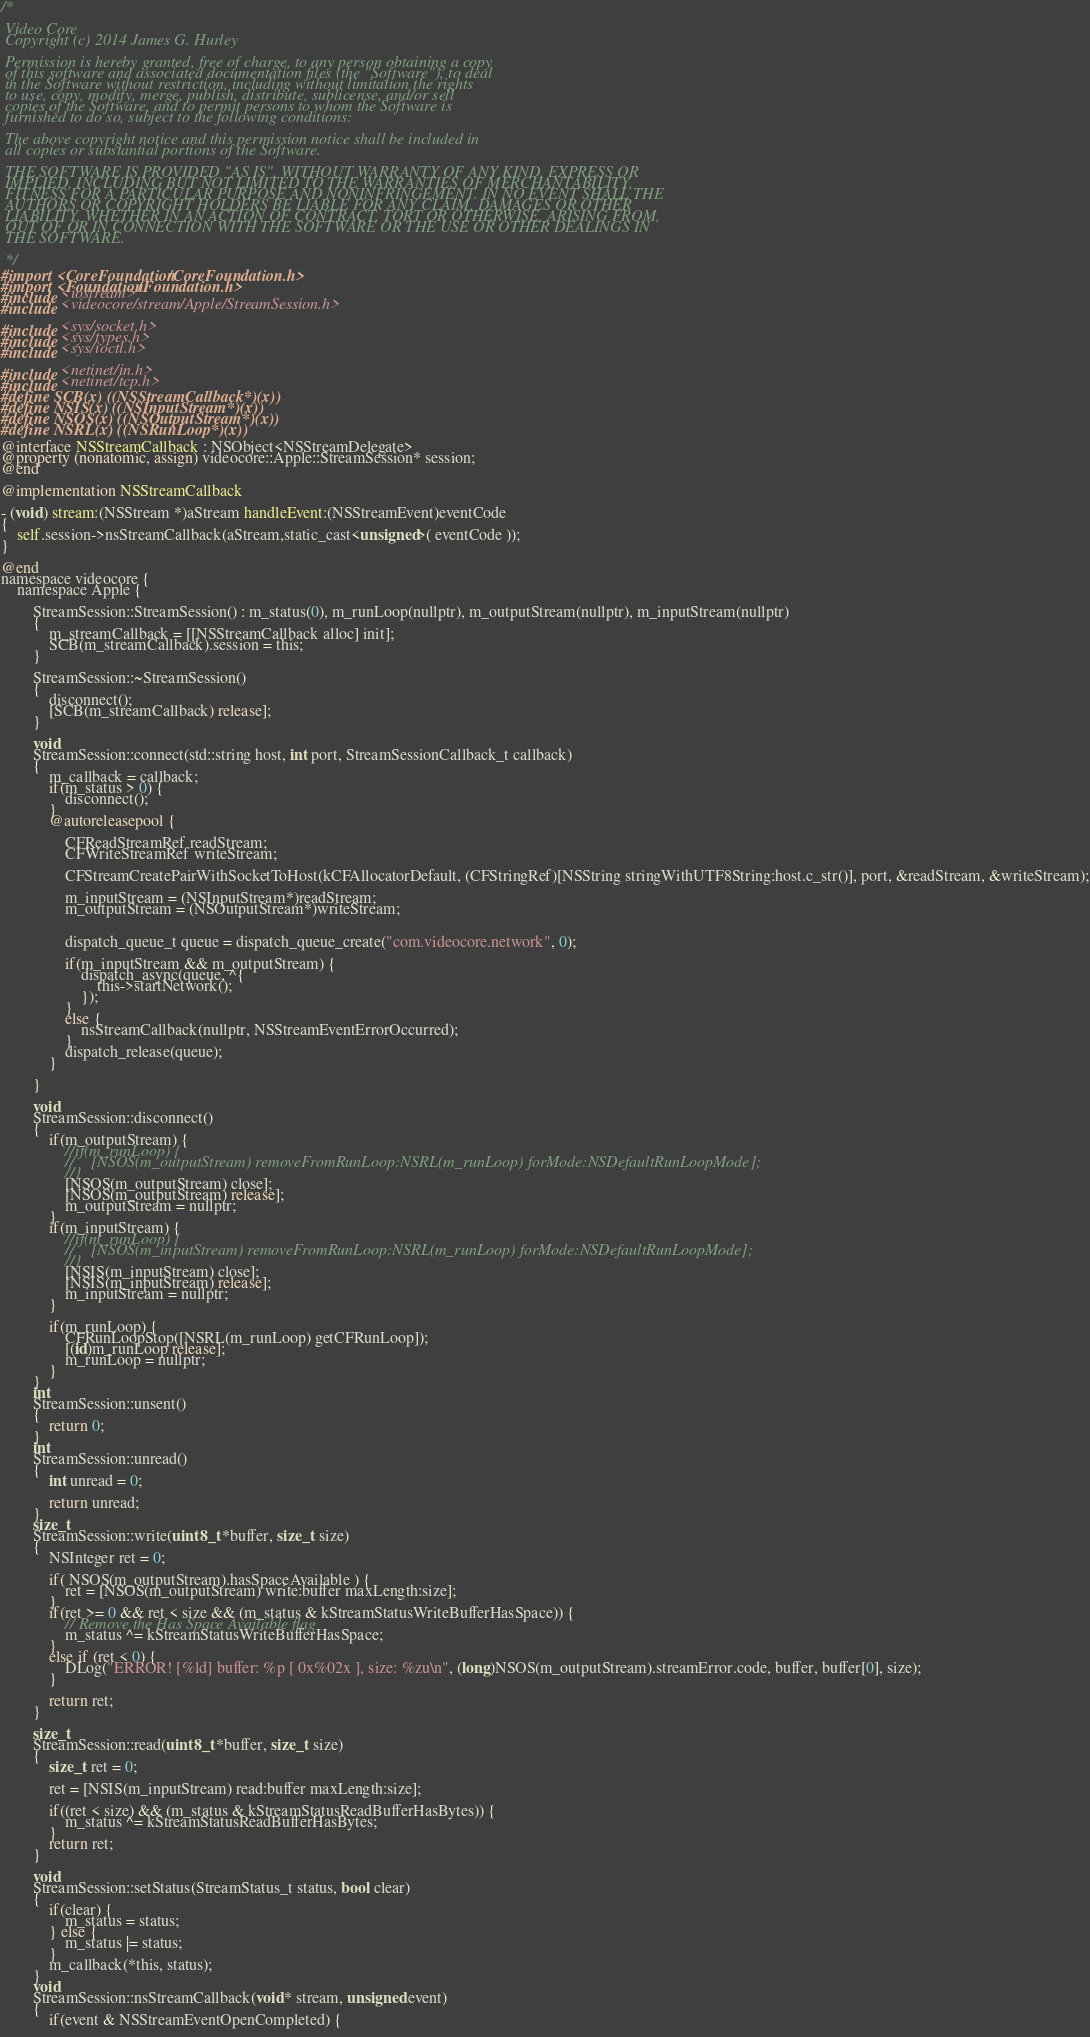<code> <loc_0><loc_0><loc_500><loc_500><_ObjectiveC_>/*
 
 Video Core
 Copyright (c) 2014 James G. Hurley
 
 Permission is hereby granted, free of charge, to any person obtaining a copy
 of this software and associated documentation files (the "Software"), to deal
 in the Software without restriction, including without limitation the rights
 to use, copy, modify, merge, publish, distribute, sublicense, and/or sell
 copies of the Software, and to permit persons to whom the Software is
 furnished to do so, subject to the following conditions:
 
 The above copyright notice and this permission notice shall be included in
 all copies or substantial portions of the Software.
 
 THE SOFTWARE IS PROVIDED "AS IS", WITHOUT WARRANTY OF ANY KIND, EXPRESS OR
 IMPLIED, INCLUDING BUT NOT LIMITED TO THE WARRANTIES OF MERCHANTABILITY,
 FITNESS FOR A PARTICULAR PURPOSE AND NONINFRINGEMENT. IN NO EVENT SHALL THE
 AUTHORS OR COPYRIGHT HOLDERS BE LIABLE FOR ANY CLAIM, DAMAGES OR OTHER
 LIABILITY, WHETHER IN AN ACTION OF CONTRACT, TORT OR OTHERWISE, ARISING FROM,
 OUT OF OR IN CONNECTION WITH THE SOFTWARE OR THE USE OR OTHER DEALINGS IN
 THE SOFTWARE.
 
 */
#import <CoreFoundation/CoreFoundation.h>
#import <Foundation/Foundation.h>
#include <iostream>
#include <videocore/stream/Apple/StreamSession.h>

#include <sys/socket.h>
#include <sys/types.h>
#include <sys/ioctl.h>

#include <netinet/in.h>
#include <netinet/tcp.h>
#define SCB(x) ((NSStreamCallback*)(x))
#define NSIS(x) ((NSInputStream*)(x))
#define NSOS(x) ((NSOutputStream*)(x))
#define NSRL(x) ((NSRunLoop*)(x))

@interface NSStreamCallback : NSObject<NSStreamDelegate>
@property (nonatomic, assign) videocore::Apple::StreamSession* session;
@end

@implementation NSStreamCallback

- (void) stream:(NSStream *)aStream handleEvent:(NSStreamEvent)eventCode
{
    self.session->nsStreamCallback(aStream,static_cast<unsigned>( eventCode ));
}

@end
namespace videocore {
    namespace Apple {
        
        StreamSession::StreamSession() : m_status(0), m_runLoop(nullptr), m_outputStream(nullptr), m_inputStream(nullptr)
        {
            m_streamCallback = [[NSStreamCallback alloc] init];
            SCB(m_streamCallback).session = this;
        }
        
        StreamSession::~StreamSession()
        {
            disconnect();
            [SCB(m_streamCallback) release];
        }
        
        void
        StreamSession::connect(std::string host, int port, StreamSessionCallback_t callback)
        {
            m_callback = callback;
            if(m_status > 0) {
                disconnect();
            }
            @autoreleasepool {
                
                CFReadStreamRef readStream;
                CFWriteStreamRef writeStream;

                CFStreamCreatePairWithSocketToHost(kCFAllocatorDefault, (CFStringRef)[NSString stringWithUTF8String:host.c_str()], port, &readStream, &writeStream);
            
                m_inputStream = (NSInputStream*)readStream;
                m_outputStream = (NSOutputStream*)writeStream;
            

                dispatch_queue_t queue = dispatch_queue_create("com.videocore.network", 0);
                
                if(m_inputStream && m_outputStream) {
                    dispatch_async(queue, ^{
                        this->startNetwork();
                    });
                }
                else {
                    nsStreamCallback(nullptr, NSStreamEventErrorOccurred);
                }
                dispatch_release(queue);
            }

        }
        
        void
        StreamSession::disconnect()
        {
            if(m_outputStream) {
                //if(m_runLoop) {
                //    [NSOS(m_outputStream) removeFromRunLoop:NSRL(m_runLoop) forMode:NSDefaultRunLoopMode];
                //}
                [NSOS(m_outputStream) close];
                [NSOS(m_outputStream) release];
                m_outputStream = nullptr;
            }
            if(m_inputStream) {
                //if(m_runLoop) {
                //    [NSOS(m_inputStream) removeFromRunLoop:NSRL(m_runLoop) forMode:NSDefaultRunLoopMode];
                //}
                [NSIS(m_inputStream) close];
                [NSIS(m_inputStream) release];
                m_inputStream = nullptr;
            }

            if(m_runLoop) {
                CFRunLoopStop([NSRL(m_runLoop) getCFRunLoop]);
                [(id)m_runLoop release];
                m_runLoop = nullptr;
            }
        }
        int
        StreamSession::unsent()
        {
            return 0;
        }
        int
        StreamSession::unread()
        {
            int unread = 0;
            
            return unread;
        }
        size_t
        StreamSession::write(uint8_t *buffer, size_t size)
        {
            NSInteger ret = 0;
          
            if( NSOS(m_outputStream).hasSpaceAvailable ) {
                ret = [NSOS(m_outputStream) write:buffer maxLength:size];
            }
            if(ret >= 0 && ret < size && (m_status & kStreamStatusWriteBufferHasSpace)) {
                // Remove the Has Space Available flag
                m_status ^= kStreamStatusWriteBufferHasSpace;
            }
            else if (ret < 0) {
                DLog("ERROR! [%ld] buffer: %p [ 0x%02x ], size: %zu\n", (long)NSOS(m_outputStream).streamError.code, buffer, buffer[0], size);
            }

            return ret;
        }
        
        size_t
        StreamSession::read(uint8_t *buffer, size_t size)
        {
            size_t ret = 0;
            
            ret = [NSIS(m_inputStream) read:buffer maxLength:size];
            
            if((ret < size) && (m_status & kStreamStatusReadBufferHasBytes)) {
                m_status ^= kStreamStatusReadBufferHasBytes;
            }
            return ret;
        }
        
        void
        StreamSession::setStatus(StreamStatus_t status, bool clear)
        {
            if(clear) {
                m_status = status;
            } else {
                m_status |= status;
            }
            m_callback(*this, status);
        }
        void
        StreamSession::nsStreamCallback(void* stream, unsigned event)
        {
            if(event & NSStreamEventOpenCompleted) {
                </code> 